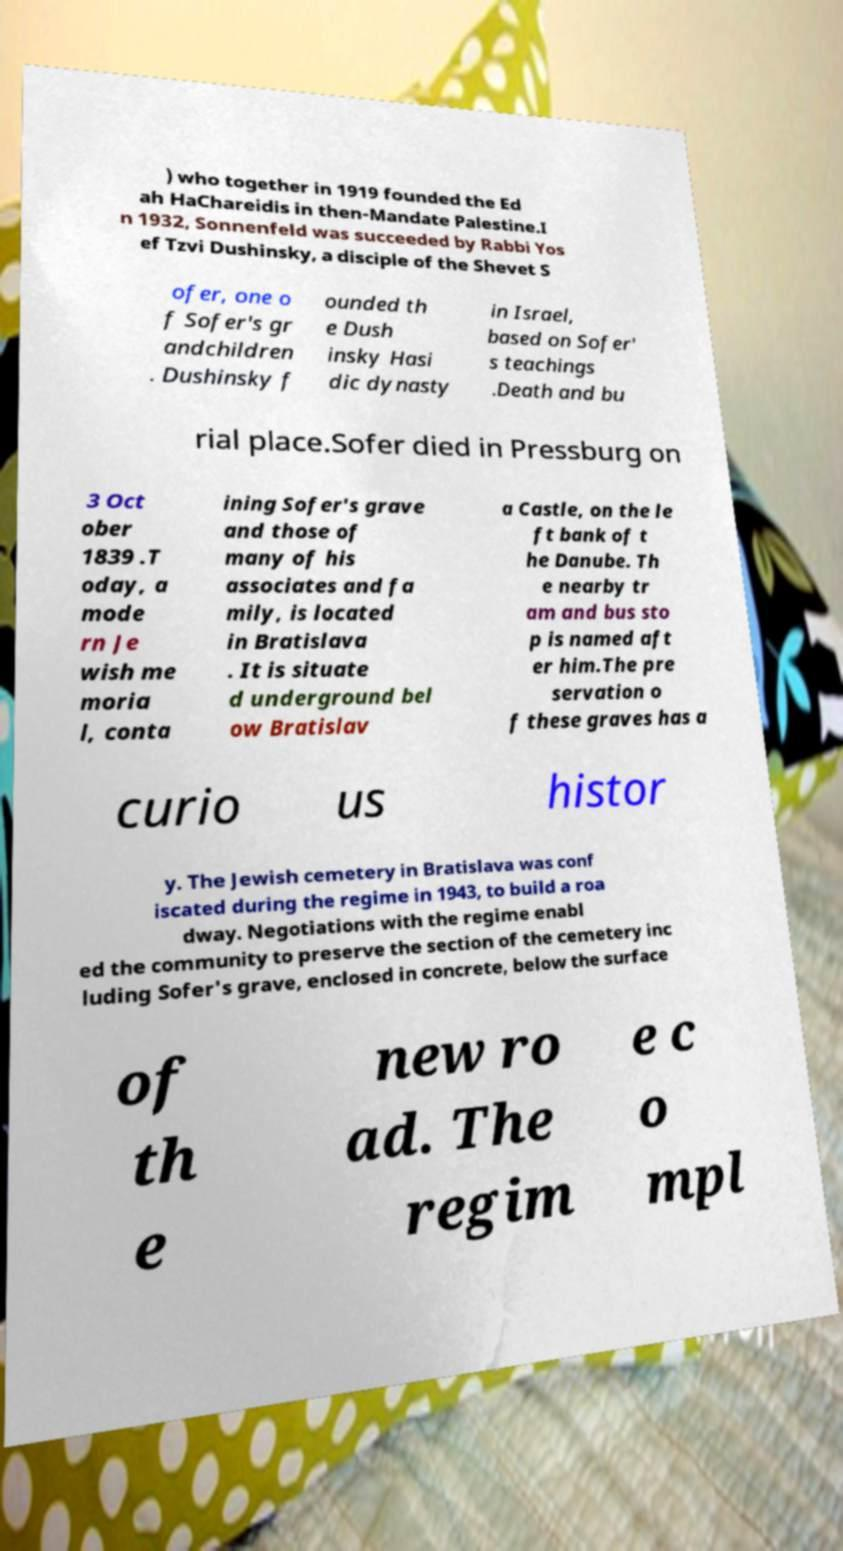Could you assist in decoding the text presented in this image and type it out clearly? ) who together in 1919 founded the Ed ah HaChareidis in then-Mandate Palestine.I n 1932, Sonnenfeld was succeeded by Rabbi Yos ef Tzvi Dushinsky, a disciple of the Shevet S ofer, one o f Sofer's gr andchildren . Dushinsky f ounded th e Dush insky Hasi dic dynasty in Israel, based on Sofer' s teachings .Death and bu rial place.Sofer died in Pressburg on 3 Oct ober 1839 .T oday, a mode rn Je wish me moria l, conta ining Sofer's grave and those of many of his associates and fa mily, is located in Bratislava . It is situate d underground bel ow Bratislav a Castle, on the le ft bank of t he Danube. Th e nearby tr am and bus sto p is named aft er him.The pre servation o f these graves has a curio us histor y. The Jewish cemetery in Bratislava was conf iscated during the regime in 1943, to build a roa dway. Negotiations with the regime enabl ed the community to preserve the section of the cemetery inc luding Sofer's grave, enclosed in concrete, below the surface of th e new ro ad. The regim e c o mpl 